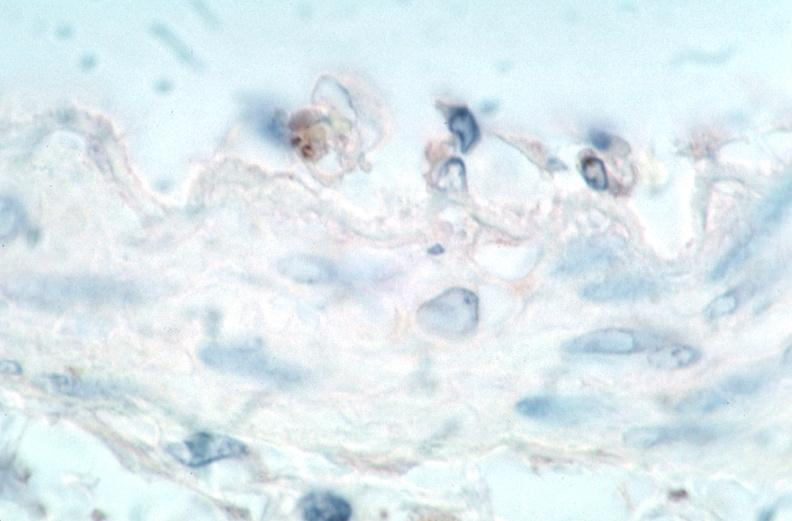what spotted fever , immunoperoxidase staining vessels for rickettsia rickettsii?
Answer the question using a single word or phrase. Vasculitis rocky mountain 